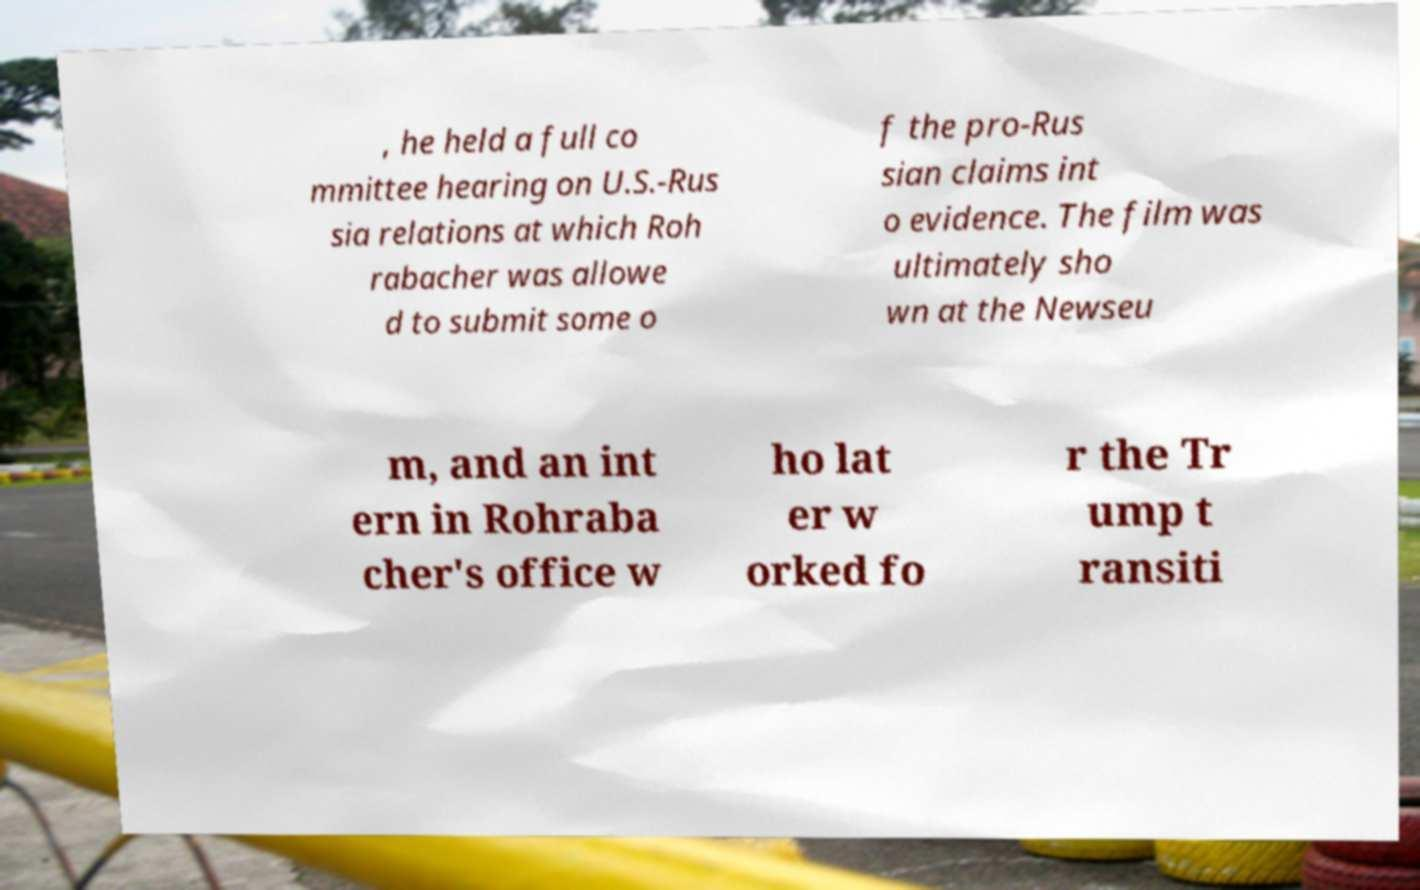Can you accurately transcribe the text from the provided image for me? , he held a full co mmittee hearing on U.S.-Rus sia relations at which Roh rabacher was allowe d to submit some o f the pro-Rus sian claims int o evidence. The film was ultimately sho wn at the Newseu m, and an int ern in Rohraba cher's office w ho lat er w orked fo r the Tr ump t ransiti 